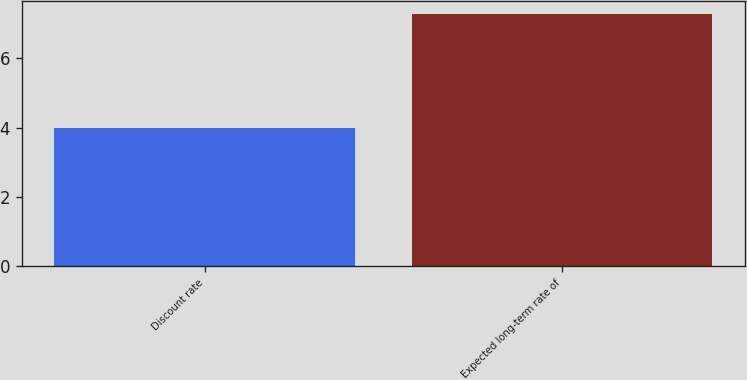Convert chart. <chart><loc_0><loc_0><loc_500><loc_500><bar_chart><fcel>Discount rate<fcel>Expected long-term rate of<nl><fcel>4<fcel>7.3<nl></chart> 